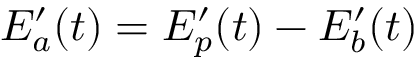Convert formula to latex. <formula><loc_0><loc_0><loc_500><loc_500>E _ { a } ^ { \prime } ( t ) = E _ { p } ^ { \prime } ( t ) - E _ { b } ^ { \prime } ( t )</formula> 